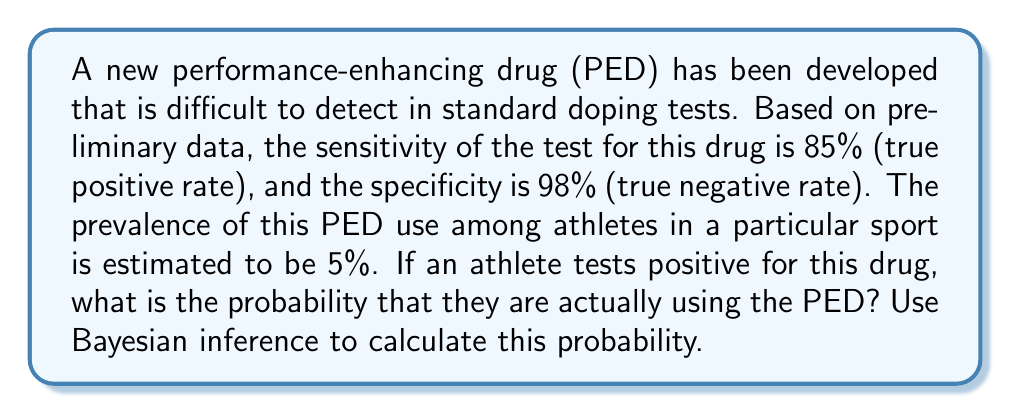Give your solution to this math problem. To solve this problem, we'll use Bayes' theorem, which is expressed as:

$$P(A|B) = \frac{P(B|A) \cdot P(A)}{P(B)}$$

Where:
A = The athlete is using the PED
B = The athlete tests positive

Given:
- Sensitivity (true positive rate) = P(B|A) = 0.85
- Specificity (true negative rate) = P(not B|not A) = 0.98
- Prevalence = P(A) = 0.05

Step 1: Calculate P(not A) = 1 - P(A) = 1 - 0.05 = 0.95

Step 2: Calculate P(B) using the law of total probability:
$$P(B) = P(B|A) \cdot P(A) + P(B|not A) \cdot P(not A)$$
$$P(B) = 0.85 \cdot 0.05 + (1 - 0.98) \cdot 0.95$$
$$P(B) = 0.0425 + 0.019 = 0.0615$$

Step 3: Apply Bayes' theorem:
$$P(A|B) = \frac{P(B|A) \cdot P(A)}{P(B)}$$
$$P(A|B) = \frac{0.85 \cdot 0.05}{0.0615}$$
$$P(A|B) = \frac{0.0425}{0.0615} \approx 0.6911$$

Therefore, the probability that an athlete who tests positive is actually using the PED is approximately 0.6911 or 69.11%.
Answer: 0.6911 